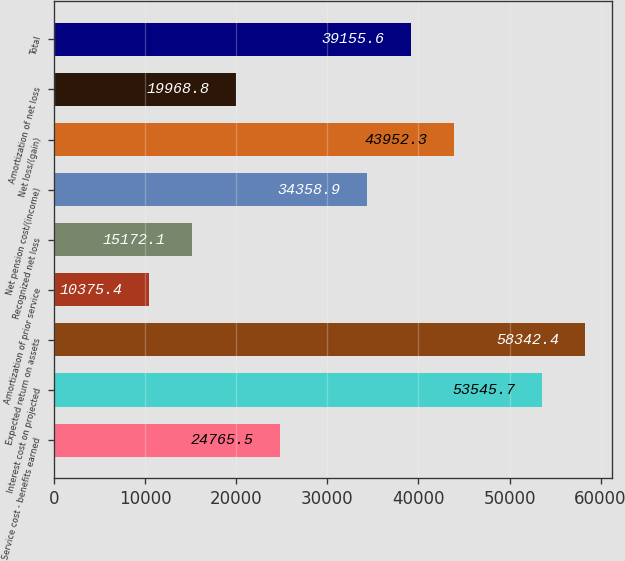Convert chart to OTSL. <chart><loc_0><loc_0><loc_500><loc_500><bar_chart><fcel>Service cost - benefits earned<fcel>Interest cost on projected<fcel>Expected return on assets<fcel>Amortization of prior service<fcel>Recognized net loss<fcel>Net pension cost/(income)<fcel>Net loss/(gain)<fcel>Amortization of net loss<fcel>Total<nl><fcel>24765.5<fcel>53545.7<fcel>58342.4<fcel>10375.4<fcel>15172.1<fcel>34358.9<fcel>43952.3<fcel>19968.8<fcel>39155.6<nl></chart> 